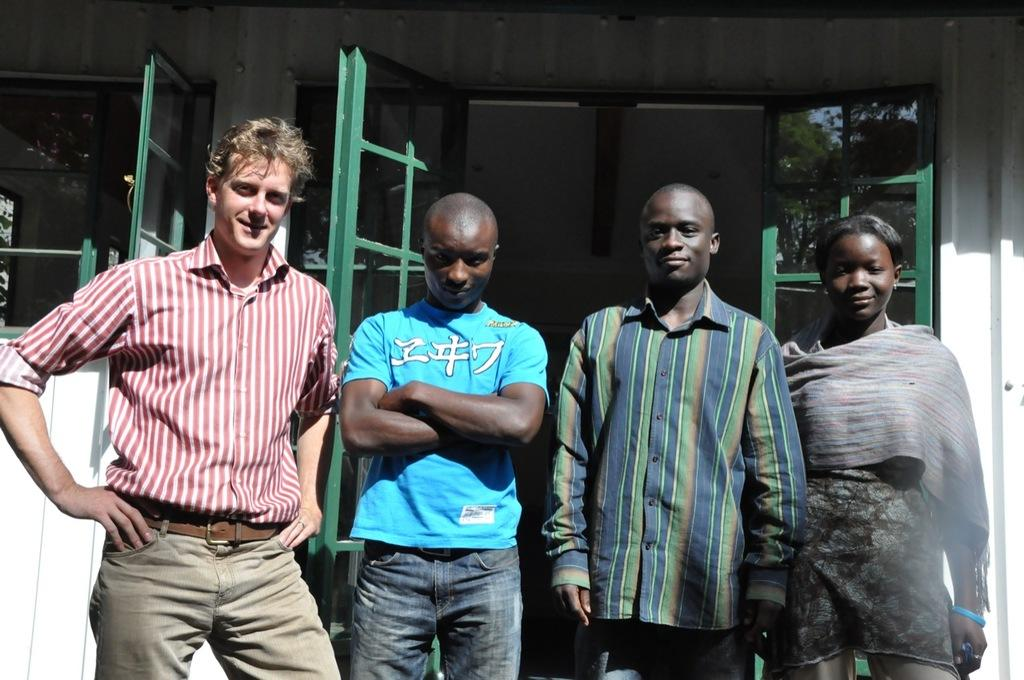How many people are in the image? There are four people in the image. What are the people doing in the image? The people are standing in front of a door and posing for a photo. What is the value of the kettle in the image? There is no kettle present in the image, so it is not possible to determine its value. 